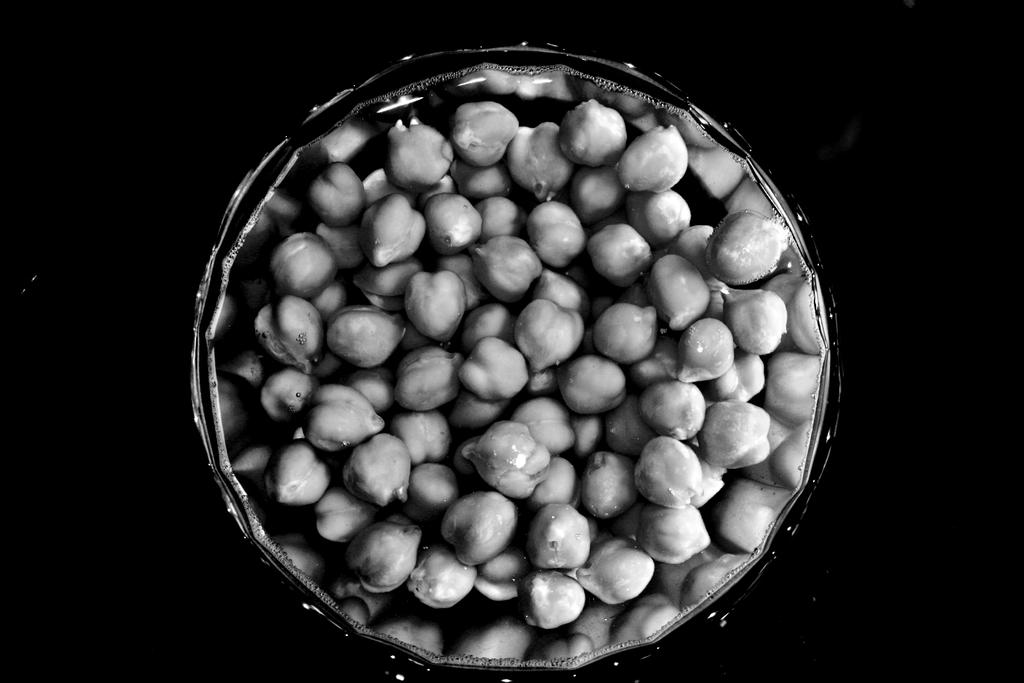What is in the bowl that is visible in the image? There is food in a bowl in the image. What can be observed about the background of the image? The background of the image is dark. What type of grape can be seen on the scale in the image? There is no grape or scale present in the image. What key is used to unlock the door in the image? There is no door or key present in the image. 